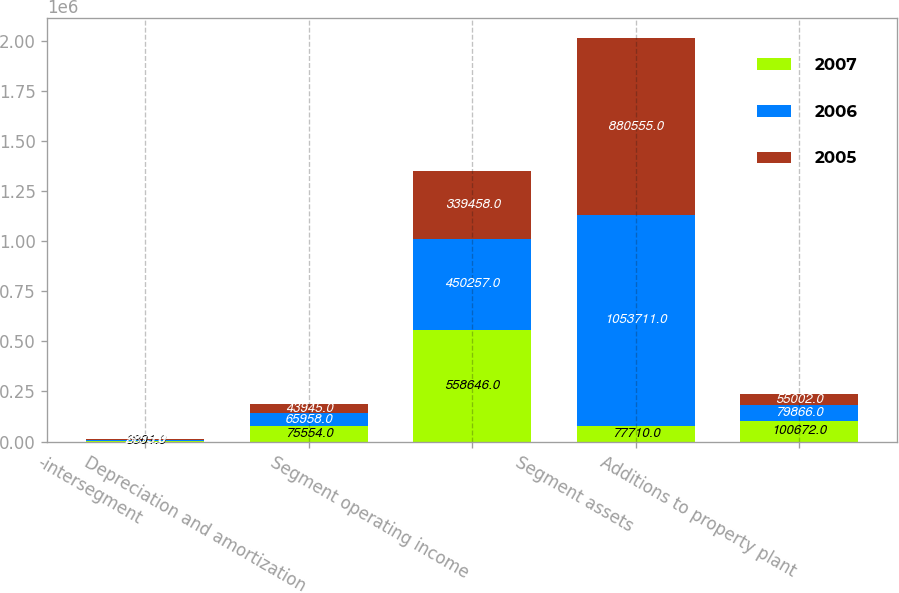Convert chart. <chart><loc_0><loc_0><loc_500><loc_500><stacked_bar_chart><ecel><fcel>-intersegment<fcel>Depreciation and amortization<fcel>Segment operating income<fcel>Segment assets<fcel>Additions to property plant<nl><fcel>2007<fcel>3901<fcel>75554<fcel>558646<fcel>77710<fcel>100672<nl><fcel>2006<fcel>3875<fcel>65958<fcel>450257<fcel>1.05371e+06<fcel>79866<nl><fcel>2005<fcel>2755<fcel>43945<fcel>339458<fcel>880555<fcel>55002<nl></chart> 